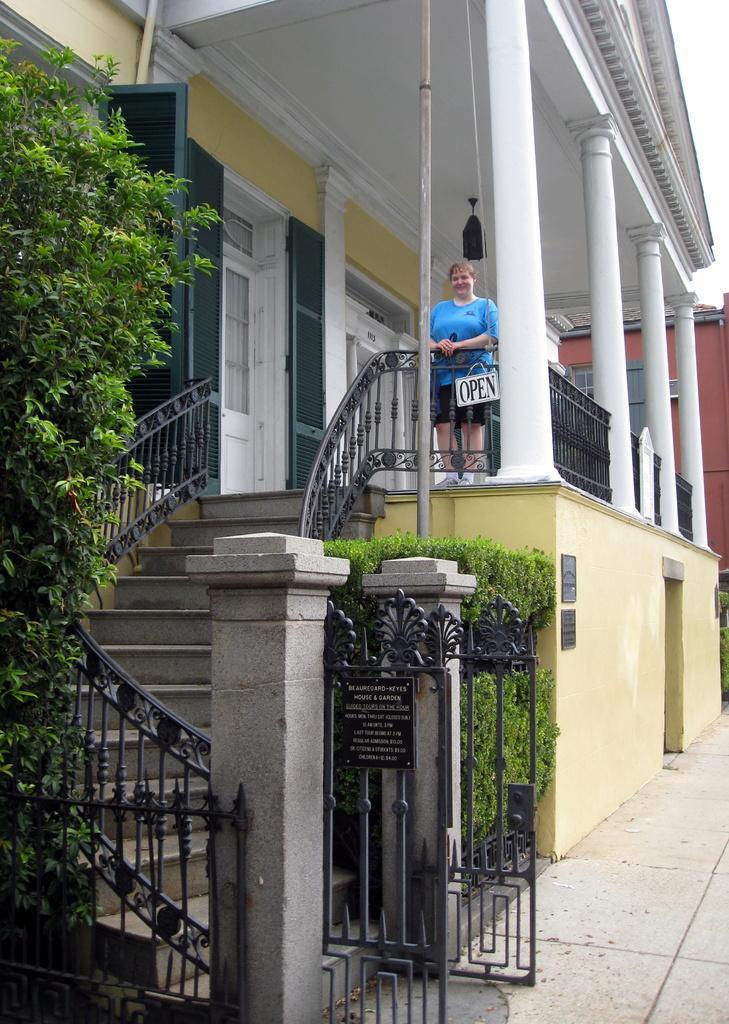In one or two sentences, can you explain what this image depicts? In this image we can see a woman standing on the surface. To the left side of the image we can see a tree, staircase with railing. In the foreground we can see gates, board with some text and some plants. In the background, we can see buildings with doors, pillars and the sky. 